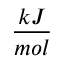Convert formula to latex. <formula><loc_0><loc_0><loc_500><loc_500>\frac { k J } { m o l }</formula> 